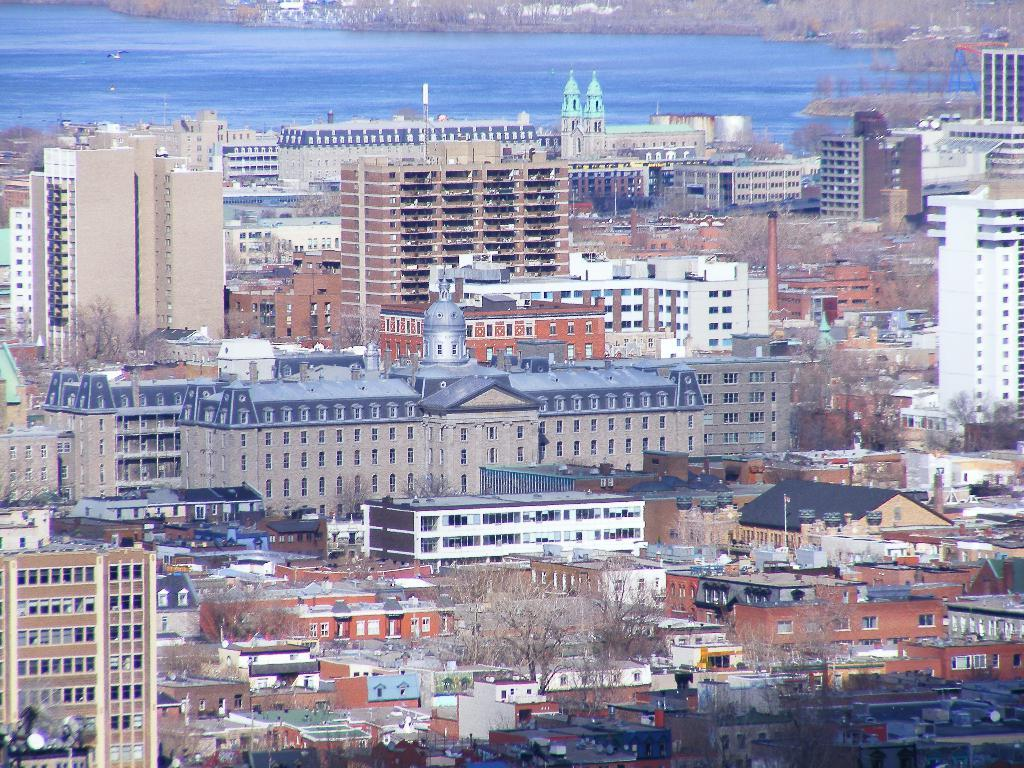What type of structures can be seen in the image? There are many buildings in the image. What other natural elements are present in the image? There are trees in the middle of the image. What body of water is visible in the image? There is a lake visible behind the buildings and trees. What type of minister is conducting a flight in the image? There is no minister or flight present in the image. Can you spot a rabbit hiding among the trees in the image? There is no rabbit present in the image. 